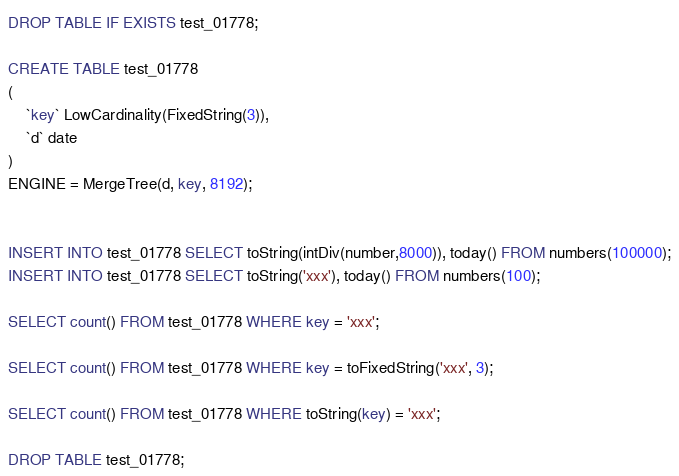Convert code to text. <code><loc_0><loc_0><loc_500><loc_500><_SQL_>DROP TABLE IF EXISTS test_01778;

CREATE TABLE test_01778
(
    `key` LowCardinality(FixedString(3)),
    `d` date
)
ENGINE = MergeTree(d, key, 8192);


INSERT INTO test_01778 SELECT toString(intDiv(number,8000)), today() FROM numbers(100000);
INSERT INTO test_01778 SELECT toString('xxx'), today() FROM numbers(100);

SELECT count() FROM test_01778 WHERE key = 'xxx';

SELECT count() FROM test_01778 WHERE key = toFixedString('xxx', 3);

SELECT count() FROM test_01778 WHERE toString(key) = 'xxx';

DROP TABLE test_01778;

</code> 